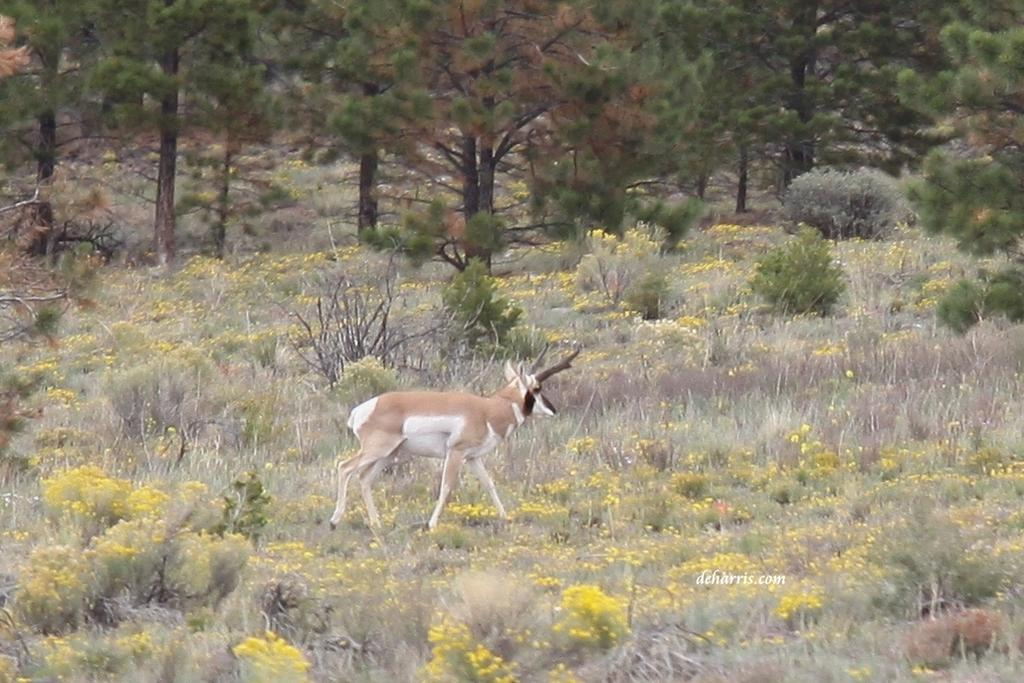What animal can be seen in the image? There is a deer in the image. Where is the deer located? The deer is standing on the grassland. What can be seen in the background of the image? There are plants and trees in the background of the image. What type of bread is the deer holding in its mouth in the image? There is no bread present in the image; the deer is not holding anything in its mouth. 